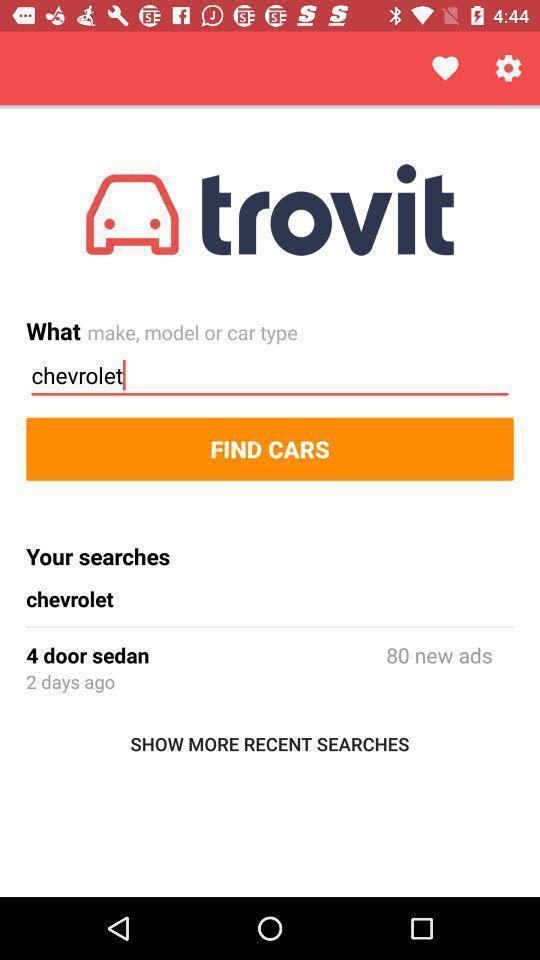Summarize the main components in this picture. Page shows to find cars in the car searching app. 